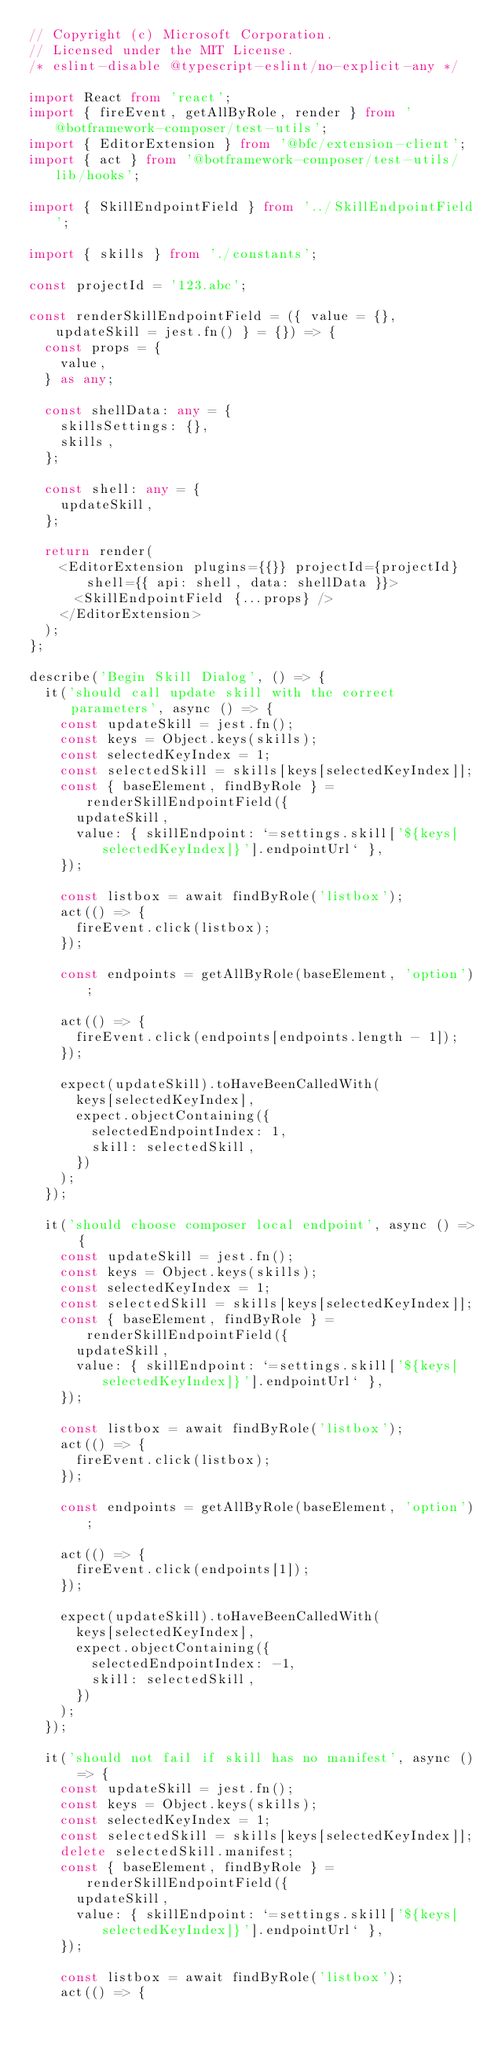<code> <loc_0><loc_0><loc_500><loc_500><_TypeScript_>// Copyright (c) Microsoft Corporation.
// Licensed under the MIT License.
/* eslint-disable @typescript-eslint/no-explicit-any */

import React from 'react';
import { fireEvent, getAllByRole, render } from '@botframework-composer/test-utils';
import { EditorExtension } from '@bfc/extension-client';
import { act } from '@botframework-composer/test-utils/lib/hooks';

import { SkillEndpointField } from '../SkillEndpointField';

import { skills } from './constants';

const projectId = '123.abc';

const renderSkillEndpointField = ({ value = {}, updateSkill = jest.fn() } = {}) => {
  const props = {
    value,
  } as any;

  const shellData: any = {
    skillsSettings: {},
    skills,
  };

  const shell: any = {
    updateSkill,
  };

  return render(
    <EditorExtension plugins={{}} projectId={projectId} shell={{ api: shell, data: shellData }}>
      <SkillEndpointField {...props} />
    </EditorExtension>
  );
};

describe('Begin Skill Dialog', () => {
  it('should call update skill with the correct parameters', async () => {
    const updateSkill = jest.fn();
    const keys = Object.keys(skills);
    const selectedKeyIndex = 1;
    const selectedSkill = skills[keys[selectedKeyIndex]];
    const { baseElement, findByRole } = renderSkillEndpointField({
      updateSkill,
      value: { skillEndpoint: `=settings.skill['${keys[selectedKeyIndex]}'].endpointUrl` },
    });

    const listbox = await findByRole('listbox');
    act(() => {
      fireEvent.click(listbox);
    });

    const endpoints = getAllByRole(baseElement, 'option');

    act(() => {
      fireEvent.click(endpoints[endpoints.length - 1]);
    });

    expect(updateSkill).toHaveBeenCalledWith(
      keys[selectedKeyIndex],
      expect.objectContaining({
        selectedEndpointIndex: 1,
        skill: selectedSkill,
      })
    );
  });

  it('should choose composer local endpoint', async () => {
    const updateSkill = jest.fn();
    const keys = Object.keys(skills);
    const selectedKeyIndex = 1;
    const selectedSkill = skills[keys[selectedKeyIndex]];
    const { baseElement, findByRole } = renderSkillEndpointField({
      updateSkill,
      value: { skillEndpoint: `=settings.skill['${keys[selectedKeyIndex]}'].endpointUrl` },
    });

    const listbox = await findByRole('listbox');
    act(() => {
      fireEvent.click(listbox);
    });

    const endpoints = getAllByRole(baseElement, 'option');

    act(() => {
      fireEvent.click(endpoints[1]);
    });

    expect(updateSkill).toHaveBeenCalledWith(
      keys[selectedKeyIndex],
      expect.objectContaining({
        selectedEndpointIndex: -1,
        skill: selectedSkill,
      })
    );
  });

  it('should not fail if skill has no manifest', async () => {
    const updateSkill = jest.fn();
    const keys = Object.keys(skills);
    const selectedKeyIndex = 1;
    const selectedSkill = skills[keys[selectedKeyIndex]];
    delete selectedSkill.manifest;
    const { baseElement, findByRole } = renderSkillEndpointField({
      updateSkill,
      value: { skillEndpoint: `=settings.skill['${keys[selectedKeyIndex]}'].endpointUrl` },
    });

    const listbox = await findByRole('listbox');
    act(() => {</code> 